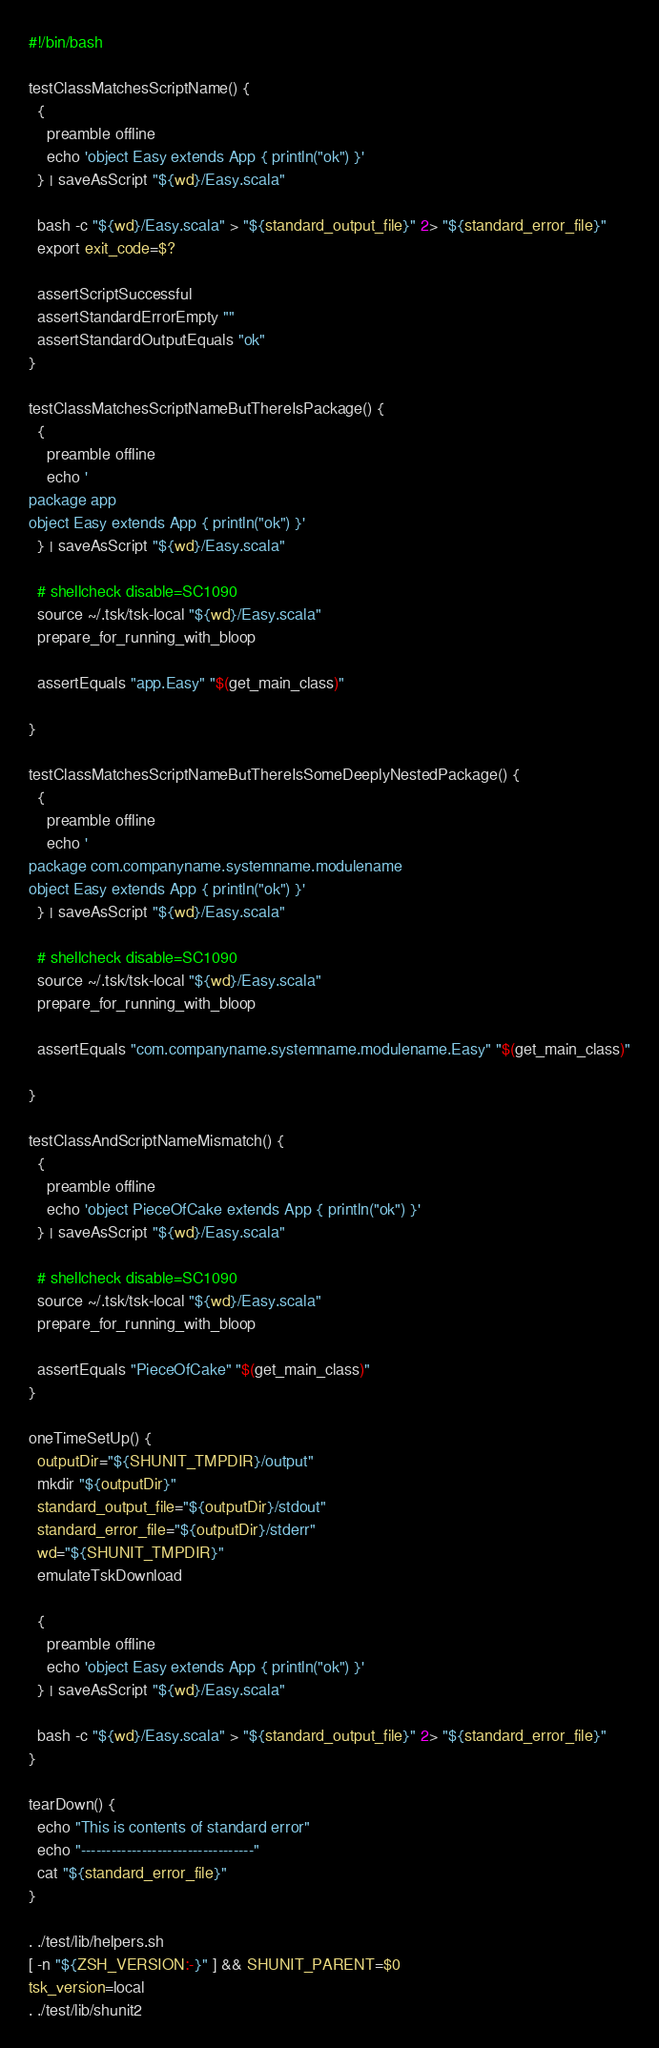<code> <loc_0><loc_0><loc_500><loc_500><_Bash_>#!/bin/bash

testClassMatchesScriptName() {
  {
    preamble offline
    echo 'object Easy extends App { println("ok") }'
  } | saveAsScript "${wd}/Easy.scala"

  bash -c "${wd}/Easy.scala" > "${standard_output_file}" 2> "${standard_error_file}"
  export exit_code=$?

  assertScriptSuccessful
  assertStandardErrorEmpty ""
  assertStandardOutputEquals "ok"
}

testClassMatchesScriptNameButThereIsPackage() {
  {
    preamble offline
    echo '
package app
object Easy extends App { println("ok") }'
  } | saveAsScript "${wd}/Easy.scala"

  # shellcheck disable=SC1090
  source ~/.tsk/tsk-local "${wd}/Easy.scala"
  prepare_for_running_with_bloop

  assertEquals "app.Easy" "$(get_main_class)"

}

testClassMatchesScriptNameButThereIsSomeDeeplyNestedPackage() {
  {
    preamble offline
    echo '
package com.companyname.systemname.modulename
object Easy extends App { println("ok") }'
  } | saveAsScript "${wd}/Easy.scala"

  # shellcheck disable=SC1090
  source ~/.tsk/tsk-local "${wd}/Easy.scala"
  prepare_for_running_with_bloop

  assertEquals "com.companyname.systemname.modulename.Easy" "$(get_main_class)"

}

testClassAndScriptNameMismatch() {
  {
    preamble offline
    echo 'object PieceOfCake extends App { println("ok") }'
  } | saveAsScript "${wd}/Easy.scala"

  # shellcheck disable=SC1090
  source ~/.tsk/tsk-local "${wd}/Easy.scala"
  prepare_for_running_with_bloop

  assertEquals "PieceOfCake" "$(get_main_class)"
}

oneTimeSetUp() {
  outputDir="${SHUNIT_TMPDIR}/output"
  mkdir "${outputDir}"
  standard_output_file="${outputDir}/stdout"
  standard_error_file="${outputDir}/stderr"
  wd="${SHUNIT_TMPDIR}"
  emulateTskDownload

  {
    preamble offline
    echo 'object Easy extends App { println("ok") }'
  } | saveAsScript "${wd}/Easy.scala"

  bash -c "${wd}/Easy.scala" > "${standard_output_file}" 2> "${standard_error_file}"
}

tearDown() {
  echo "This is contents of standard error"
  echo "----------------------------------"
  cat "${standard_error_file}"
}

. ./test/lib/helpers.sh
[ -n "${ZSH_VERSION:-}" ] && SHUNIT_PARENT=$0
tsk_version=local
. ./test/lib/shunit2
</code> 